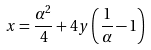Convert formula to latex. <formula><loc_0><loc_0><loc_500><loc_500>x = \frac { \alpha ^ { 2 } } { 4 } + 4 y \left ( \frac { 1 } { \alpha } - 1 \right )</formula> 